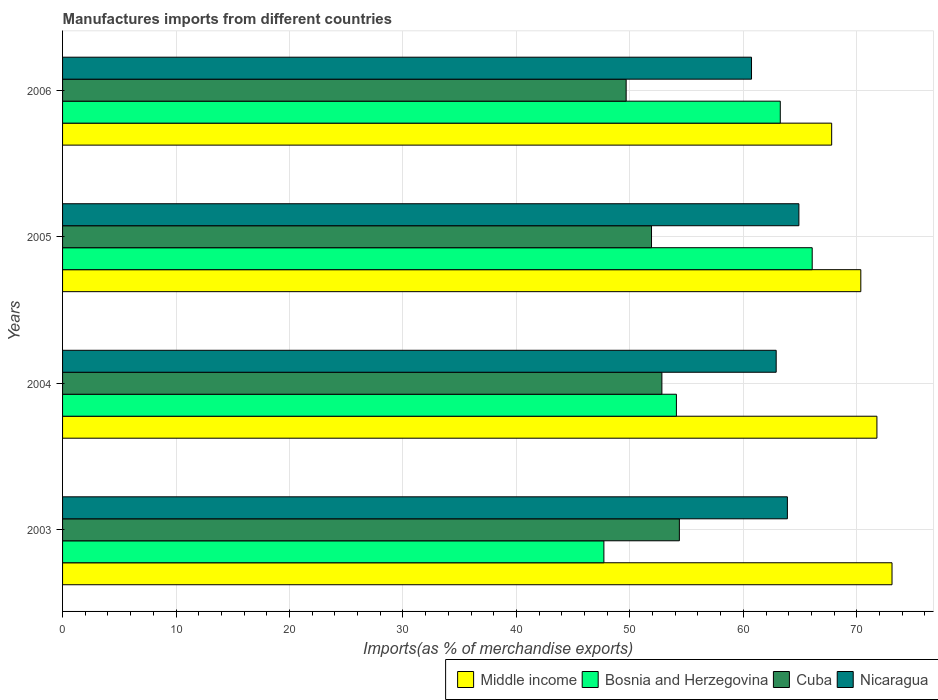How many different coloured bars are there?
Make the answer very short. 4. Are the number of bars per tick equal to the number of legend labels?
Your response must be concise. Yes. What is the percentage of imports to different countries in Bosnia and Herzegovina in 2003?
Your response must be concise. 47.71. Across all years, what is the maximum percentage of imports to different countries in Nicaragua?
Offer a very short reply. 64.89. Across all years, what is the minimum percentage of imports to different countries in Bosnia and Herzegovina?
Provide a short and direct response. 47.71. In which year was the percentage of imports to different countries in Middle income maximum?
Your answer should be very brief. 2003. In which year was the percentage of imports to different countries in Nicaragua minimum?
Give a very brief answer. 2006. What is the total percentage of imports to different countries in Middle income in the graph?
Provide a succinct answer. 283. What is the difference between the percentage of imports to different countries in Middle income in 2004 and that in 2005?
Provide a succinct answer. 1.42. What is the difference between the percentage of imports to different countries in Bosnia and Herzegovina in 2005 and the percentage of imports to different countries in Cuba in 2003?
Offer a terse response. 11.71. What is the average percentage of imports to different countries in Nicaragua per year?
Give a very brief answer. 63.1. In the year 2006, what is the difference between the percentage of imports to different countries in Bosnia and Herzegovina and percentage of imports to different countries in Middle income?
Offer a very short reply. -4.53. In how many years, is the percentage of imports to different countries in Middle income greater than 32 %?
Provide a succinct answer. 4. What is the ratio of the percentage of imports to different countries in Nicaragua in 2005 to that in 2006?
Keep it short and to the point. 1.07. Is the percentage of imports to different countries in Nicaragua in 2004 less than that in 2006?
Provide a short and direct response. No. What is the difference between the highest and the second highest percentage of imports to different countries in Middle income?
Offer a terse response. 1.33. What is the difference between the highest and the lowest percentage of imports to different countries in Nicaragua?
Give a very brief answer. 4.17. In how many years, is the percentage of imports to different countries in Bosnia and Herzegovina greater than the average percentage of imports to different countries in Bosnia and Herzegovina taken over all years?
Provide a succinct answer. 2. Is the sum of the percentage of imports to different countries in Cuba in 2004 and 2006 greater than the maximum percentage of imports to different countries in Bosnia and Herzegovina across all years?
Your response must be concise. Yes. Is it the case that in every year, the sum of the percentage of imports to different countries in Cuba and percentage of imports to different countries in Bosnia and Herzegovina is greater than the sum of percentage of imports to different countries in Middle income and percentage of imports to different countries in Nicaragua?
Give a very brief answer. No. What does the 3rd bar from the top in 2005 represents?
Your answer should be very brief. Bosnia and Herzegovina. What does the 2nd bar from the bottom in 2004 represents?
Provide a short and direct response. Bosnia and Herzegovina. Are all the bars in the graph horizontal?
Provide a succinct answer. Yes. Are the values on the major ticks of X-axis written in scientific E-notation?
Provide a short and direct response. No. Does the graph contain any zero values?
Offer a terse response. No. How are the legend labels stacked?
Ensure brevity in your answer.  Horizontal. What is the title of the graph?
Your answer should be compact. Manufactures imports from different countries. What is the label or title of the X-axis?
Offer a terse response. Imports(as % of merchandise exports). What is the Imports(as % of merchandise exports) of Middle income in 2003?
Provide a succinct answer. 73.1. What is the Imports(as % of merchandise exports) in Bosnia and Herzegovina in 2003?
Keep it short and to the point. 47.71. What is the Imports(as % of merchandise exports) of Cuba in 2003?
Make the answer very short. 54.36. What is the Imports(as % of merchandise exports) of Nicaragua in 2003?
Your response must be concise. 63.88. What is the Imports(as % of merchandise exports) in Middle income in 2004?
Provide a succinct answer. 71.77. What is the Imports(as % of merchandise exports) of Bosnia and Herzegovina in 2004?
Provide a succinct answer. 54.1. What is the Imports(as % of merchandise exports) of Cuba in 2004?
Offer a terse response. 52.82. What is the Imports(as % of merchandise exports) in Nicaragua in 2004?
Offer a very short reply. 62.89. What is the Imports(as % of merchandise exports) of Middle income in 2005?
Keep it short and to the point. 70.35. What is the Imports(as % of merchandise exports) in Bosnia and Herzegovina in 2005?
Provide a short and direct response. 66.07. What is the Imports(as % of merchandise exports) in Cuba in 2005?
Provide a short and direct response. 51.9. What is the Imports(as % of merchandise exports) of Nicaragua in 2005?
Provide a short and direct response. 64.89. What is the Imports(as % of merchandise exports) of Middle income in 2006?
Ensure brevity in your answer.  67.78. What is the Imports(as % of merchandise exports) in Bosnia and Herzegovina in 2006?
Your answer should be compact. 63.25. What is the Imports(as % of merchandise exports) in Cuba in 2006?
Your response must be concise. 49.67. What is the Imports(as % of merchandise exports) of Nicaragua in 2006?
Offer a very short reply. 60.72. Across all years, what is the maximum Imports(as % of merchandise exports) in Middle income?
Provide a short and direct response. 73.1. Across all years, what is the maximum Imports(as % of merchandise exports) of Bosnia and Herzegovina?
Keep it short and to the point. 66.07. Across all years, what is the maximum Imports(as % of merchandise exports) of Cuba?
Make the answer very short. 54.36. Across all years, what is the maximum Imports(as % of merchandise exports) of Nicaragua?
Provide a succinct answer. 64.89. Across all years, what is the minimum Imports(as % of merchandise exports) of Middle income?
Offer a terse response. 67.78. Across all years, what is the minimum Imports(as % of merchandise exports) of Bosnia and Herzegovina?
Offer a very short reply. 47.71. Across all years, what is the minimum Imports(as % of merchandise exports) of Cuba?
Give a very brief answer. 49.67. Across all years, what is the minimum Imports(as % of merchandise exports) of Nicaragua?
Offer a terse response. 60.72. What is the total Imports(as % of merchandise exports) in Middle income in the graph?
Give a very brief answer. 283. What is the total Imports(as % of merchandise exports) of Bosnia and Herzegovina in the graph?
Your answer should be compact. 231.13. What is the total Imports(as % of merchandise exports) of Cuba in the graph?
Offer a very short reply. 208.75. What is the total Imports(as % of merchandise exports) of Nicaragua in the graph?
Your answer should be very brief. 252.38. What is the difference between the Imports(as % of merchandise exports) in Middle income in 2003 and that in 2004?
Your answer should be compact. 1.33. What is the difference between the Imports(as % of merchandise exports) in Bosnia and Herzegovina in 2003 and that in 2004?
Your response must be concise. -6.39. What is the difference between the Imports(as % of merchandise exports) of Cuba in 2003 and that in 2004?
Provide a succinct answer. 1.54. What is the difference between the Imports(as % of merchandise exports) in Nicaragua in 2003 and that in 2004?
Your answer should be very brief. 0.99. What is the difference between the Imports(as % of merchandise exports) in Middle income in 2003 and that in 2005?
Your answer should be very brief. 2.75. What is the difference between the Imports(as % of merchandise exports) of Bosnia and Herzegovina in 2003 and that in 2005?
Provide a short and direct response. -18.36. What is the difference between the Imports(as % of merchandise exports) of Cuba in 2003 and that in 2005?
Your answer should be very brief. 2.46. What is the difference between the Imports(as % of merchandise exports) of Nicaragua in 2003 and that in 2005?
Keep it short and to the point. -1.01. What is the difference between the Imports(as % of merchandise exports) in Middle income in 2003 and that in 2006?
Provide a short and direct response. 5.32. What is the difference between the Imports(as % of merchandise exports) of Bosnia and Herzegovina in 2003 and that in 2006?
Keep it short and to the point. -15.54. What is the difference between the Imports(as % of merchandise exports) in Cuba in 2003 and that in 2006?
Provide a short and direct response. 4.69. What is the difference between the Imports(as % of merchandise exports) of Nicaragua in 2003 and that in 2006?
Make the answer very short. 3.16. What is the difference between the Imports(as % of merchandise exports) of Middle income in 2004 and that in 2005?
Offer a terse response. 1.42. What is the difference between the Imports(as % of merchandise exports) of Bosnia and Herzegovina in 2004 and that in 2005?
Make the answer very short. -11.97. What is the difference between the Imports(as % of merchandise exports) in Cuba in 2004 and that in 2005?
Give a very brief answer. 0.92. What is the difference between the Imports(as % of merchandise exports) of Nicaragua in 2004 and that in 2005?
Offer a very short reply. -2. What is the difference between the Imports(as % of merchandise exports) in Middle income in 2004 and that in 2006?
Offer a terse response. 3.99. What is the difference between the Imports(as % of merchandise exports) in Bosnia and Herzegovina in 2004 and that in 2006?
Offer a terse response. -9.15. What is the difference between the Imports(as % of merchandise exports) of Cuba in 2004 and that in 2006?
Give a very brief answer. 3.15. What is the difference between the Imports(as % of merchandise exports) of Nicaragua in 2004 and that in 2006?
Ensure brevity in your answer.  2.17. What is the difference between the Imports(as % of merchandise exports) of Middle income in 2005 and that in 2006?
Keep it short and to the point. 2.57. What is the difference between the Imports(as % of merchandise exports) in Bosnia and Herzegovina in 2005 and that in 2006?
Provide a succinct answer. 2.81. What is the difference between the Imports(as % of merchandise exports) in Cuba in 2005 and that in 2006?
Your answer should be compact. 2.23. What is the difference between the Imports(as % of merchandise exports) in Nicaragua in 2005 and that in 2006?
Provide a succinct answer. 4.17. What is the difference between the Imports(as % of merchandise exports) in Middle income in 2003 and the Imports(as % of merchandise exports) in Bosnia and Herzegovina in 2004?
Your response must be concise. 19. What is the difference between the Imports(as % of merchandise exports) in Middle income in 2003 and the Imports(as % of merchandise exports) in Cuba in 2004?
Your answer should be very brief. 20.28. What is the difference between the Imports(as % of merchandise exports) in Middle income in 2003 and the Imports(as % of merchandise exports) in Nicaragua in 2004?
Give a very brief answer. 10.21. What is the difference between the Imports(as % of merchandise exports) in Bosnia and Herzegovina in 2003 and the Imports(as % of merchandise exports) in Cuba in 2004?
Offer a terse response. -5.11. What is the difference between the Imports(as % of merchandise exports) of Bosnia and Herzegovina in 2003 and the Imports(as % of merchandise exports) of Nicaragua in 2004?
Your answer should be very brief. -15.18. What is the difference between the Imports(as % of merchandise exports) of Cuba in 2003 and the Imports(as % of merchandise exports) of Nicaragua in 2004?
Your answer should be compact. -8.53. What is the difference between the Imports(as % of merchandise exports) in Middle income in 2003 and the Imports(as % of merchandise exports) in Bosnia and Herzegovina in 2005?
Make the answer very short. 7.03. What is the difference between the Imports(as % of merchandise exports) in Middle income in 2003 and the Imports(as % of merchandise exports) in Cuba in 2005?
Ensure brevity in your answer.  21.2. What is the difference between the Imports(as % of merchandise exports) in Middle income in 2003 and the Imports(as % of merchandise exports) in Nicaragua in 2005?
Ensure brevity in your answer.  8.21. What is the difference between the Imports(as % of merchandise exports) in Bosnia and Herzegovina in 2003 and the Imports(as % of merchandise exports) in Cuba in 2005?
Your response must be concise. -4.2. What is the difference between the Imports(as % of merchandise exports) in Bosnia and Herzegovina in 2003 and the Imports(as % of merchandise exports) in Nicaragua in 2005?
Offer a terse response. -17.18. What is the difference between the Imports(as % of merchandise exports) in Cuba in 2003 and the Imports(as % of merchandise exports) in Nicaragua in 2005?
Offer a terse response. -10.53. What is the difference between the Imports(as % of merchandise exports) in Middle income in 2003 and the Imports(as % of merchandise exports) in Bosnia and Herzegovina in 2006?
Your answer should be compact. 9.85. What is the difference between the Imports(as % of merchandise exports) of Middle income in 2003 and the Imports(as % of merchandise exports) of Cuba in 2006?
Your response must be concise. 23.43. What is the difference between the Imports(as % of merchandise exports) in Middle income in 2003 and the Imports(as % of merchandise exports) in Nicaragua in 2006?
Ensure brevity in your answer.  12.38. What is the difference between the Imports(as % of merchandise exports) in Bosnia and Herzegovina in 2003 and the Imports(as % of merchandise exports) in Cuba in 2006?
Your answer should be compact. -1.96. What is the difference between the Imports(as % of merchandise exports) in Bosnia and Herzegovina in 2003 and the Imports(as % of merchandise exports) in Nicaragua in 2006?
Offer a very short reply. -13.01. What is the difference between the Imports(as % of merchandise exports) in Cuba in 2003 and the Imports(as % of merchandise exports) in Nicaragua in 2006?
Your answer should be compact. -6.36. What is the difference between the Imports(as % of merchandise exports) in Middle income in 2004 and the Imports(as % of merchandise exports) in Bosnia and Herzegovina in 2005?
Make the answer very short. 5.7. What is the difference between the Imports(as % of merchandise exports) of Middle income in 2004 and the Imports(as % of merchandise exports) of Cuba in 2005?
Ensure brevity in your answer.  19.87. What is the difference between the Imports(as % of merchandise exports) of Middle income in 2004 and the Imports(as % of merchandise exports) of Nicaragua in 2005?
Ensure brevity in your answer.  6.88. What is the difference between the Imports(as % of merchandise exports) in Bosnia and Herzegovina in 2004 and the Imports(as % of merchandise exports) in Cuba in 2005?
Provide a succinct answer. 2.19. What is the difference between the Imports(as % of merchandise exports) of Bosnia and Herzegovina in 2004 and the Imports(as % of merchandise exports) of Nicaragua in 2005?
Provide a short and direct response. -10.79. What is the difference between the Imports(as % of merchandise exports) of Cuba in 2004 and the Imports(as % of merchandise exports) of Nicaragua in 2005?
Offer a very short reply. -12.07. What is the difference between the Imports(as % of merchandise exports) of Middle income in 2004 and the Imports(as % of merchandise exports) of Bosnia and Herzegovina in 2006?
Provide a succinct answer. 8.52. What is the difference between the Imports(as % of merchandise exports) in Middle income in 2004 and the Imports(as % of merchandise exports) in Cuba in 2006?
Keep it short and to the point. 22.1. What is the difference between the Imports(as % of merchandise exports) of Middle income in 2004 and the Imports(as % of merchandise exports) of Nicaragua in 2006?
Provide a short and direct response. 11.05. What is the difference between the Imports(as % of merchandise exports) of Bosnia and Herzegovina in 2004 and the Imports(as % of merchandise exports) of Cuba in 2006?
Give a very brief answer. 4.43. What is the difference between the Imports(as % of merchandise exports) in Bosnia and Herzegovina in 2004 and the Imports(as % of merchandise exports) in Nicaragua in 2006?
Give a very brief answer. -6.62. What is the difference between the Imports(as % of merchandise exports) of Cuba in 2004 and the Imports(as % of merchandise exports) of Nicaragua in 2006?
Your answer should be compact. -7.9. What is the difference between the Imports(as % of merchandise exports) of Middle income in 2005 and the Imports(as % of merchandise exports) of Bosnia and Herzegovina in 2006?
Offer a terse response. 7.1. What is the difference between the Imports(as % of merchandise exports) of Middle income in 2005 and the Imports(as % of merchandise exports) of Cuba in 2006?
Provide a short and direct response. 20.68. What is the difference between the Imports(as % of merchandise exports) of Middle income in 2005 and the Imports(as % of merchandise exports) of Nicaragua in 2006?
Your answer should be very brief. 9.63. What is the difference between the Imports(as % of merchandise exports) of Bosnia and Herzegovina in 2005 and the Imports(as % of merchandise exports) of Cuba in 2006?
Your response must be concise. 16.4. What is the difference between the Imports(as % of merchandise exports) of Bosnia and Herzegovina in 2005 and the Imports(as % of merchandise exports) of Nicaragua in 2006?
Offer a terse response. 5.35. What is the difference between the Imports(as % of merchandise exports) of Cuba in 2005 and the Imports(as % of merchandise exports) of Nicaragua in 2006?
Your answer should be compact. -8.81. What is the average Imports(as % of merchandise exports) in Middle income per year?
Your answer should be very brief. 70.75. What is the average Imports(as % of merchandise exports) in Bosnia and Herzegovina per year?
Provide a succinct answer. 57.78. What is the average Imports(as % of merchandise exports) in Cuba per year?
Provide a short and direct response. 52.19. What is the average Imports(as % of merchandise exports) in Nicaragua per year?
Keep it short and to the point. 63.1. In the year 2003, what is the difference between the Imports(as % of merchandise exports) of Middle income and Imports(as % of merchandise exports) of Bosnia and Herzegovina?
Your response must be concise. 25.39. In the year 2003, what is the difference between the Imports(as % of merchandise exports) of Middle income and Imports(as % of merchandise exports) of Cuba?
Give a very brief answer. 18.74. In the year 2003, what is the difference between the Imports(as % of merchandise exports) in Middle income and Imports(as % of merchandise exports) in Nicaragua?
Give a very brief answer. 9.22. In the year 2003, what is the difference between the Imports(as % of merchandise exports) in Bosnia and Herzegovina and Imports(as % of merchandise exports) in Cuba?
Make the answer very short. -6.65. In the year 2003, what is the difference between the Imports(as % of merchandise exports) in Bosnia and Herzegovina and Imports(as % of merchandise exports) in Nicaragua?
Offer a very short reply. -16.17. In the year 2003, what is the difference between the Imports(as % of merchandise exports) in Cuba and Imports(as % of merchandise exports) in Nicaragua?
Make the answer very short. -9.52. In the year 2004, what is the difference between the Imports(as % of merchandise exports) in Middle income and Imports(as % of merchandise exports) in Bosnia and Herzegovina?
Your answer should be very brief. 17.67. In the year 2004, what is the difference between the Imports(as % of merchandise exports) in Middle income and Imports(as % of merchandise exports) in Cuba?
Your answer should be compact. 18.95. In the year 2004, what is the difference between the Imports(as % of merchandise exports) of Middle income and Imports(as % of merchandise exports) of Nicaragua?
Provide a short and direct response. 8.88. In the year 2004, what is the difference between the Imports(as % of merchandise exports) of Bosnia and Herzegovina and Imports(as % of merchandise exports) of Cuba?
Keep it short and to the point. 1.28. In the year 2004, what is the difference between the Imports(as % of merchandise exports) in Bosnia and Herzegovina and Imports(as % of merchandise exports) in Nicaragua?
Provide a short and direct response. -8.79. In the year 2004, what is the difference between the Imports(as % of merchandise exports) in Cuba and Imports(as % of merchandise exports) in Nicaragua?
Offer a terse response. -10.07. In the year 2005, what is the difference between the Imports(as % of merchandise exports) of Middle income and Imports(as % of merchandise exports) of Bosnia and Herzegovina?
Ensure brevity in your answer.  4.28. In the year 2005, what is the difference between the Imports(as % of merchandise exports) of Middle income and Imports(as % of merchandise exports) of Cuba?
Keep it short and to the point. 18.45. In the year 2005, what is the difference between the Imports(as % of merchandise exports) of Middle income and Imports(as % of merchandise exports) of Nicaragua?
Ensure brevity in your answer.  5.46. In the year 2005, what is the difference between the Imports(as % of merchandise exports) of Bosnia and Herzegovina and Imports(as % of merchandise exports) of Cuba?
Provide a short and direct response. 14.16. In the year 2005, what is the difference between the Imports(as % of merchandise exports) in Bosnia and Herzegovina and Imports(as % of merchandise exports) in Nicaragua?
Provide a succinct answer. 1.17. In the year 2005, what is the difference between the Imports(as % of merchandise exports) of Cuba and Imports(as % of merchandise exports) of Nicaragua?
Make the answer very short. -12.99. In the year 2006, what is the difference between the Imports(as % of merchandise exports) in Middle income and Imports(as % of merchandise exports) in Bosnia and Herzegovina?
Offer a very short reply. 4.53. In the year 2006, what is the difference between the Imports(as % of merchandise exports) in Middle income and Imports(as % of merchandise exports) in Cuba?
Your response must be concise. 18.11. In the year 2006, what is the difference between the Imports(as % of merchandise exports) of Middle income and Imports(as % of merchandise exports) of Nicaragua?
Provide a succinct answer. 7.06. In the year 2006, what is the difference between the Imports(as % of merchandise exports) in Bosnia and Herzegovina and Imports(as % of merchandise exports) in Cuba?
Make the answer very short. 13.58. In the year 2006, what is the difference between the Imports(as % of merchandise exports) in Bosnia and Herzegovina and Imports(as % of merchandise exports) in Nicaragua?
Provide a short and direct response. 2.53. In the year 2006, what is the difference between the Imports(as % of merchandise exports) of Cuba and Imports(as % of merchandise exports) of Nicaragua?
Your response must be concise. -11.05. What is the ratio of the Imports(as % of merchandise exports) in Middle income in 2003 to that in 2004?
Provide a short and direct response. 1.02. What is the ratio of the Imports(as % of merchandise exports) of Bosnia and Herzegovina in 2003 to that in 2004?
Give a very brief answer. 0.88. What is the ratio of the Imports(as % of merchandise exports) in Cuba in 2003 to that in 2004?
Provide a short and direct response. 1.03. What is the ratio of the Imports(as % of merchandise exports) of Nicaragua in 2003 to that in 2004?
Make the answer very short. 1.02. What is the ratio of the Imports(as % of merchandise exports) in Middle income in 2003 to that in 2005?
Your response must be concise. 1.04. What is the ratio of the Imports(as % of merchandise exports) in Bosnia and Herzegovina in 2003 to that in 2005?
Give a very brief answer. 0.72. What is the ratio of the Imports(as % of merchandise exports) of Cuba in 2003 to that in 2005?
Provide a short and direct response. 1.05. What is the ratio of the Imports(as % of merchandise exports) in Nicaragua in 2003 to that in 2005?
Your answer should be very brief. 0.98. What is the ratio of the Imports(as % of merchandise exports) in Middle income in 2003 to that in 2006?
Keep it short and to the point. 1.08. What is the ratio of the Imports(as % of merchandise exports) in Bosnia and Herzegovina in 2003 to that in 2006?
Ensure brevity in your answer.  0.75. What is the ratio of the Imports(as % of merchandise exports) of Cuba in 2003 to that in 2006?
Your answer should be compact. 1.09. What is the ratio of the Imports(as % of merchandise exports) in Nicaragua in 2003 to that in 2006?
Keep it short and to the point. 1.05. What is the ratio of the Imports(as % of merchandise exports) of Middle income in 2004 to that in 2005?
Offer a very short reply. 1.02. What is the ratio of the Imports(as % of merchandise exports) of Bosnia and Herzegovina in 2004 to that in 2005?
Keep it short and to the point. 0.82. What is the ratio of the Imports(as % of merchandise exports) of Cuba in 2004 to that in 2005?
Offer a very short reply. 1.02. What is the ratio of the Imports(as % of merchandise exports) in Nicaragua in 2004 to that in 2005?
Your response must be concise. 0.97. What is the ratio of the Imports(as % of merchandise exports) of Middle income in 2004 to that in 2006?
Provide a succinct answer. 1.06. What is the ratio of the Imports(as % of merchandise exports) of Bosnia and Herzegovina in 2004 to that in 2006?
Your answer should be compact. 0.86. What is the ratio of the Imports(as % of merchandise exports) in Cuba in 2004 to that in 2006?
Your answer should be compact. 1.06. What is the ratio of the Imports(as % of merchandise exports) of Nicaragua in 2004 to that in 2006?
Offer a very short reply. 1.04. What is the ratio of the Imports(as % of merchandise exports) in Middle income in 2005 to that in 2006?
Your response must be concise. 1.04. What is the ratio of the Imports(as % of merchandise exports) of Bosnia and Herzegovina in 2005 to that in 2006?
Ensure brevity in your answer.  1.04. What is the ratio of the Imports(as % of merchandise exports) of Cuba in 2005 to that in 2006?
Give a very brief answer. 1.04. What is the ratio of the Imports(as % of merchandise exports) of Nicaragua in 2005 to that in 2006?
Provide a succinct answer. 1.07. What is the difference between the highest and the second highest Imports(as % of merchandise exports) in Middle income?
Offer a terse response. 1.33. What is the difference between the highest and the second highest Imports(as % of merchandise exports) of Bosnia and Herzegovina?
Offer a terse response. 2.81. What is the difference between the highest and the second highest Imports(as % of merchandise exports) of Cuba?
Offer a terse response. 1.54. What is the difference between the highest and the second highest Imports(as % of merchandise exports) of Nicaragua?
Keep it short and to the point. 1.01. What is the difference between the highest and the lowest Imports(as % of merchandise exports) of Middle income?
Give a very brief answer. 5.32. What is the difference between the highest and the lowest Imports(as % of merchandise exports) in Bosnia and Herzegovina?
Your response must be concise. 18.36. What is the difference between the highest and the lowest Imports(as % of merchandise exports) in Cuba?
Keep it short and to the point. 4.69. What is the difference between the highest and the lowest Imports(as % of merchandise exports) of Nicaragua?
Make the answer very short. 4.17. 